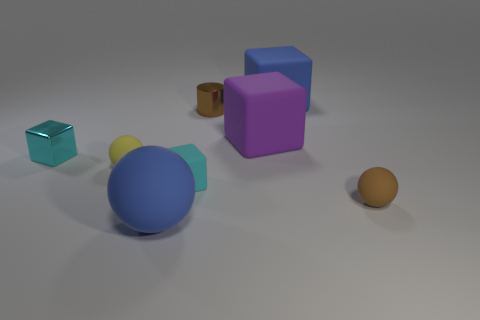What number of tiny blocks are the same color as the large rubber sphere?
Give a very brief answer. 0. Are there an equal number of tiny cubes that are on the right side of the small shiny cube and cyan things?
Your answer should be very brief. No. The large ball has what color?
Ensure brevity in your answer.  Blue. There is a thing that is the same material as the small brown cylinder; what size is it?
Offer a terse response. Small. The other tiny sphere that is made of the same material as the brown sphere is what color?
Ensure brevity in your answer.  Yellow. Is there a blue rubber object of the same size as the yellow object?
Offer a terse response. No. There is a blue thing that is the same shape as the purple rubber object; what is it made of?
Give a very brief answer. Rubber. There is a yellow matte object that is the same size as the cylinder; what is its shape?
Offer a terse response. Sphere. Is there a brown metallic object of the same shape as the tiny yellow thing?
Ensure brevity in your answer.  No. What is the shape of the brown thing behind the small rubber ball that is right of the purple matte block?
Offer a very short reply. Cylinder. 